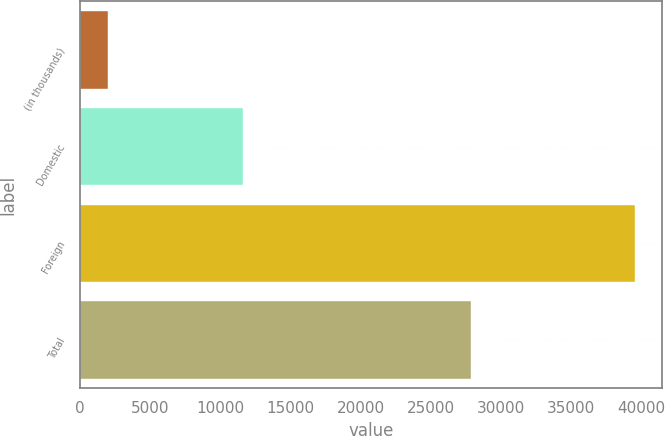<chart> <loc_0><loc_0><loc_500><loc_500><bar_chart><fcel>(in thousands)<fcel>Domestic<fcel>Foreign<fcel>Total<nl><fcel>2002<fcel>11636<fcel>39532<fcel>27896<nl></chart> 